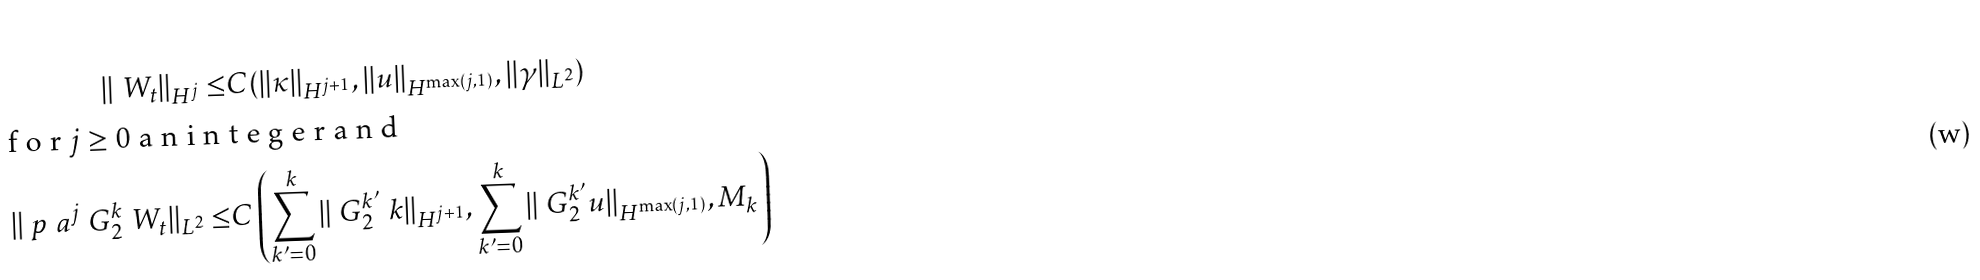Convert formula to latex. <formula><loc_0><loc_0><loc_500><loc_500>\| \ W _ { t } \| _ { H ^ { j } } \leq & C ( \| \kappa \| _ { H ^ { j + 1 } } , \| u \| _ { H ^ { \max ( j , 1 ) } } , \| \gamma \| _ { L ^ { 2 } } ) \\ \intertext { f o r $ j \geq 0 $ a n i n t e g e r a n d } \| \ p _ { \ } a ^ { j } \ G _ { 2 } ^ { k } \ W _ { t } \| _ { L ^ { 2 } } \leq & C \left ( \sum _ { k ^ { \prime } = 0 } ^ { k } \| \ G _ { 2 } ^ { k ^ { \prime } } \ k \| _ { H ^ { j + 1 } } , \sum _ { k ^ { \prime } = 0 } ^ { k } \| \ G _ { 2 } ^ { k ^ { \prime } } u \| _ { H ^ { \max ( j , 1 ) } } , M _ { k } \right )</formula> 